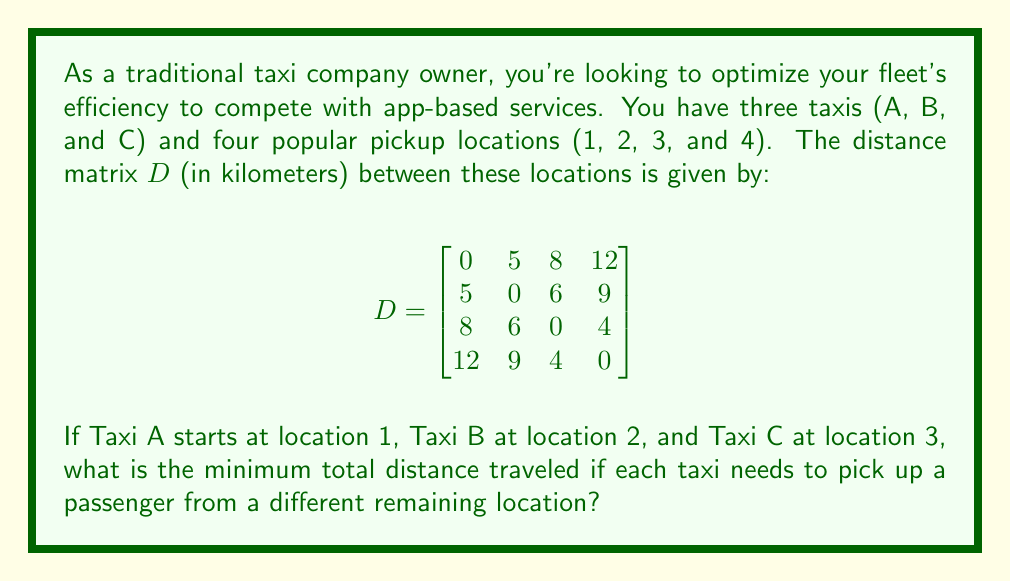Could you help me with this problem? To solve this problem, we'll use the Hungarian algorithm, which is an optimization algorithm for assignment problems. Here's how we'll approach it:

1) First, we need to create a cost matrix. Since we want to minimize the total distance, our cost will be the distances traveled.

2) We'll create a 3x3 matrix representing the distances from each taxi's starting point to the possible pickup locations:

$$C = \begin{bmatrix}
5 & 8 & 12 \\
5 & 6 & 9 \\
6 & 0 & 4
\end{bmatrix}$$

3) Now, we'll apply the Hungarian algorithm:

   Step 1: Subtract the minimum value in each row from all elements in that row.
   
   $$C_1 = \begin{bmatrix}
   0 & 3 & 7 \\
   0 & 1 & 4 \\
   6 & 0 & 4
   \end{bmatrix}$$

   Step 2: Subtract the minimum value in each column from all elements in that column.
   
   $$C_2 = \begin{bmatrix}
   0 & 2 & 3 \\
   0 & 0 & 0 \\
   6 & 0 & 0
   \end{bmatrix}$$

   Step 3: Draw lines through rows and columns to cover all zeros with the minimum number of lines.

   We can cover all zeros with 2 lines, so we proceed to the next step.

   Step 4: Find the smallest uncovered element (which is 2), subtract it from all uncovered elements and add it to elements at the intersection of covering lines.

   $$C_3 = \begin{bmatrix}
   0 & 0 & 1 \\
   0 & 0 & 0 \\
   8 & 0 & 0
   \end{bmatrix}$$

4) Now we have a zero in each row and column. The optimal assignment is:
   - Taxi A (from location 1) picks up from location 2
   - Taxi B (from location 2) picks up from location 3
   - Taxi C (from location 3) picks up from location 4

5) The total distance is therefore:
   5 (A from 1 to 2) + 6 (B from 2 to 3) + 4 (C from 3 to 4) = 15 km
Answer: The minimum total distance traveled is 15 km. 